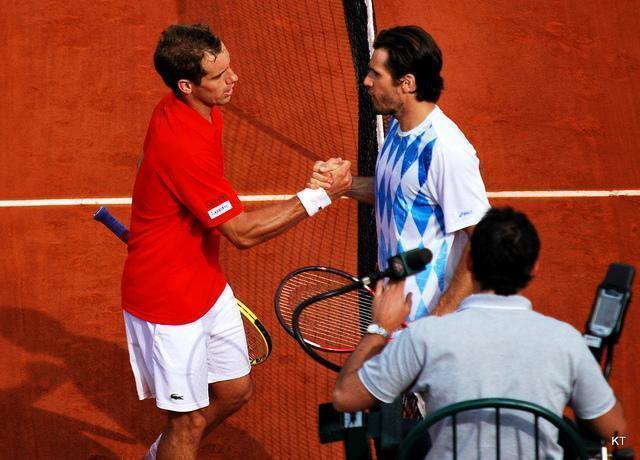What is the man in the chair known as?
Indicate the correct response and explain using: 'Answer: answer
Rationale: rationale.'
Options: Line judge, referee, adjudicator, umpire. Answer: referee.
Rationale: The man is judging the event. 